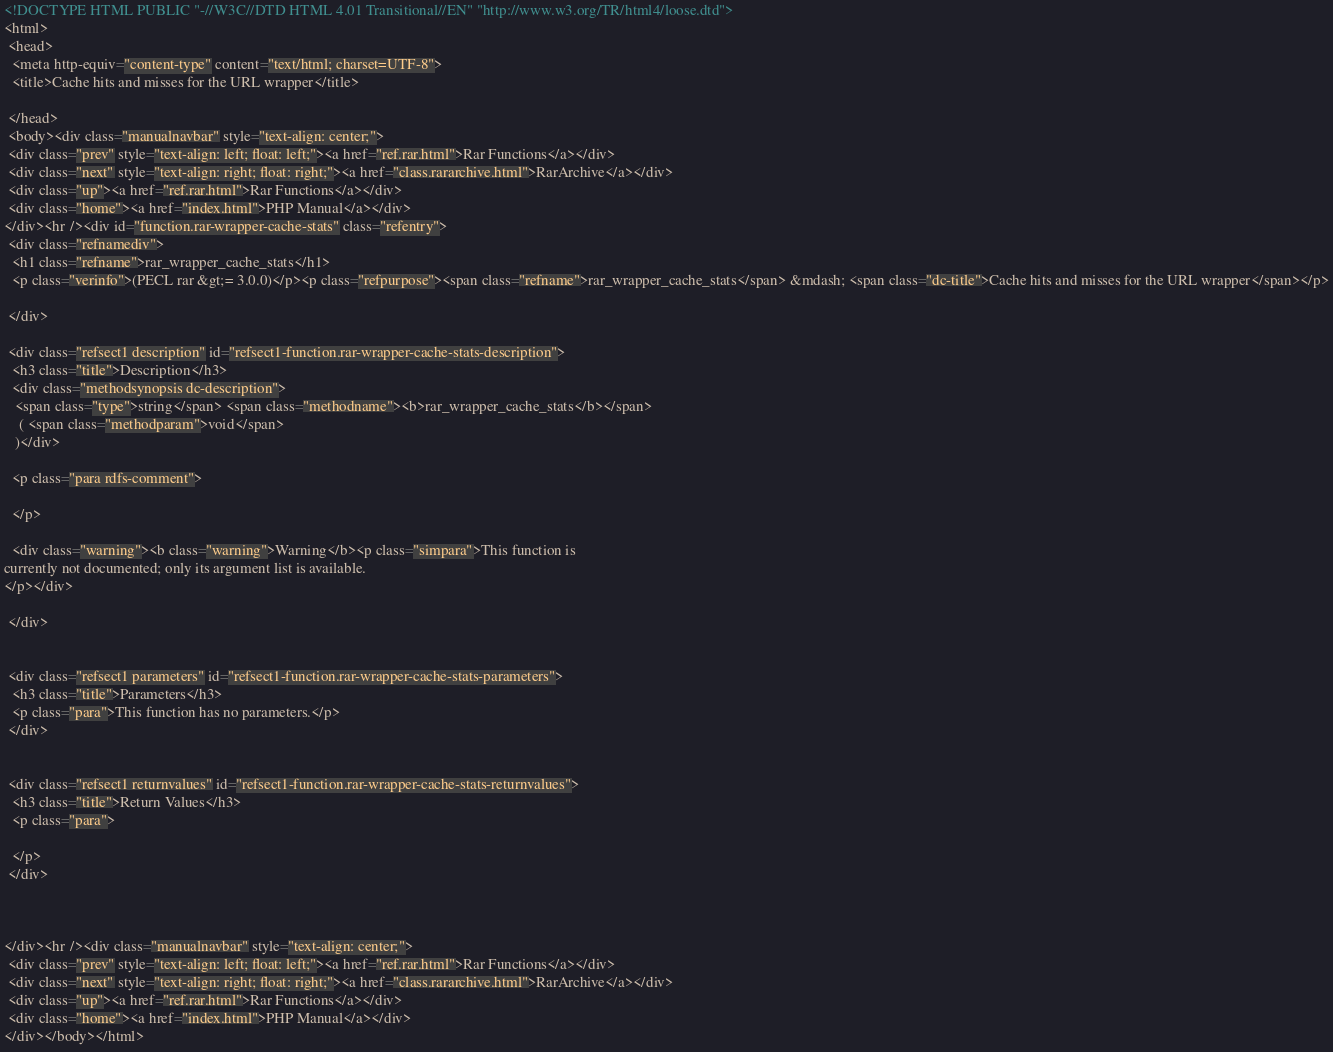Convert code to text. <code><loc_0><loc_0><loc_500><loc_500><_HTML_><!DOCTYPE HTML PUBLIC "-//W3C//DTD HTML 4.01 Transitional//EN" "http://www.w3.org/TR/html4/loose.dtd">
<html>
 <head>
  <meta http-equiv="content-type" content="text/html; charset=UTF-8">
  <title>Cache hits and misses for the URL wrapper</title>

 </head>
 <body><div class="manualnavbar" style="text-align: center;">
 <div class="prev" style="text-align: left; float: left;"><a href="ref.rar.html">Rar Functions</a></div>
 <div class="next" style="text-align: right; float: right;"><a href="class.rararchive.html">RarArchive</a></div>
 <div class="up"><a href="ref.rar.html">Rar Functions</a></div>
 <div class="home"><a href="index.html">PHP Manual</a></div>
</div><hr /><div id="function.rar-wrapper-cache-stats" class="refentry">
 <div class="refnamediv">
  <h1 class="refname">rar_wrapper_cache_stats</h1>
  <p class="verinfo">(PECL rar &gt;= 3.0.0)</p><p class="refpurpose"><span class="refname">rar_wrapper_cache_stats</span> &mdash; <span class="dc-title">Cache hits and misses for the URL wrapper</span></p>

 </div>

 <div class="refsect1 description" id="refsect1-function.rar-wrapper-cache-stats-description">
  <h3 class="title">Description</h3>
  <div class="methodsynopsis dc-description">
   <span class="type">string</span> <span class="methodname"><b>rar_wrapper_cache_stats</b></span>
    ( <span class="methodparam">void</span>
   )</div>

  <p class="para rdfs-comment">

  </p>

  <div class="warning"><b class="warning">Warning</b><p class="simpara">This function is
currently not documented; only its argument list is available.
</p></div>

 </div>


 <div class="refsect1 parameters" id="refsect1-function.rar-wrapper-cache-stats-parameters">
  <h3 class="title">Parameters</h3>
  <p class="para">This function has no parameters.</p>
 </div>


 <div class="refsect1 returnvalues" id="refsect1-function.rar-wrapper-cache-stats-returnvalues">
  <h3 class="title">Return Values</h3>
  <p class="para">
   
  </p>
 </div>



</div><hr /><div class="manualnavbar" style="text-align: center;">
 <div class="prev" style="text-align: left; float: left;"><a href="ref.rar.html">Rar Functions</a></div>
 <div class="next" style="text-align: right; float: right;"><a href="class.rararchive.html">RarArchive</a></div>
 <div class="up"><a href="ref.rar.html">Rar Functions</a></div>
 <div class="home"><a href="index.html">PHP Manual</a></div>
</div></body></html>
</code> 